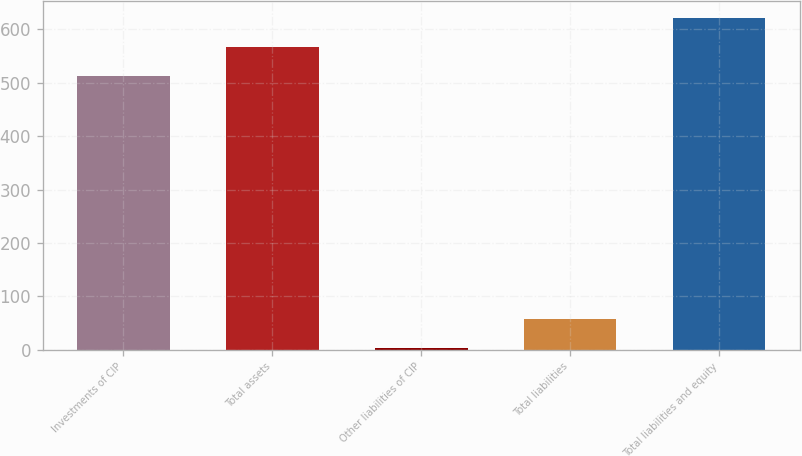<chart> <loc_0><loc_0><loc_500><loc_500><bar_chart><fcel>Investments of CIP<fcel>Total assets<fcel>Other liabilities of CIP<fcel>Total liabilities<fcel>Total liabilities and equity<nl><fcel>512.2<fcel>566.87<fcel>3<fcel>57.67<fcel>621.54<nl></chart> 